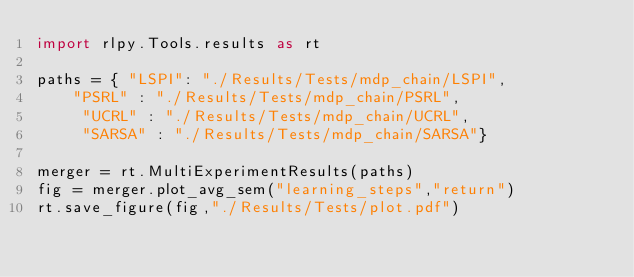<code> <loc_0><loc_0><loc_500><loc_500><_Python_>import rlpy.Tools.results as rt

paths = { "LSPI": "./Results/Tests/mdp_chain/LSPI",
	"PSRL" : "./Results/Tests/mdp_chain/PSRL",
     "UCRL" : "./Results/Tests/mdp_chain/UCRL",
     "SARSA" : "./Results/Tests/mdp_chain/SARSA"}

merger = rt.MultiExperimentResults(paths)
fig = merger.plot_avg_sem("learning_steps","return")
rt.save_figure(fig,"./Results/Tests/plot.pdf")
</code> 